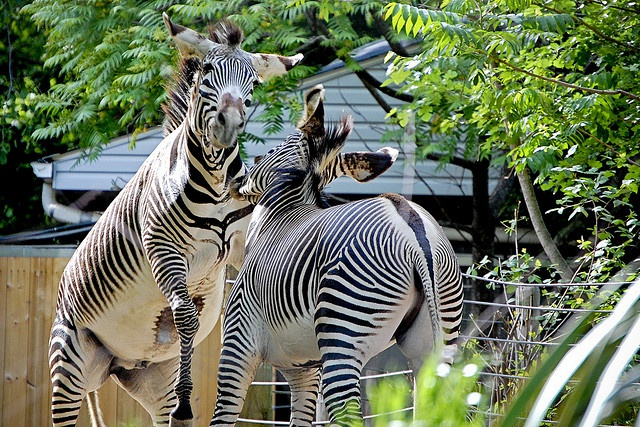Describe the objects in this image and their specific colors. I can see zebra in darkgreen, black, darkgray, gray, and lightgray tones and zebra in darkgreen, darkgray, black, white, and tan tones in this image. 